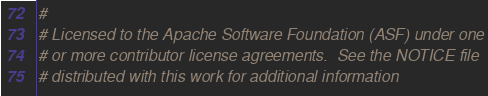Convert code to text. <code><loc_0><loc_0><loc_500><loc_500><_Python_>#
# Licensed to the Apache Software Foundation (ASF) under one
# or more contributor license agreements.  See the NOTICE file
# distributed with this work for additional information</code> 